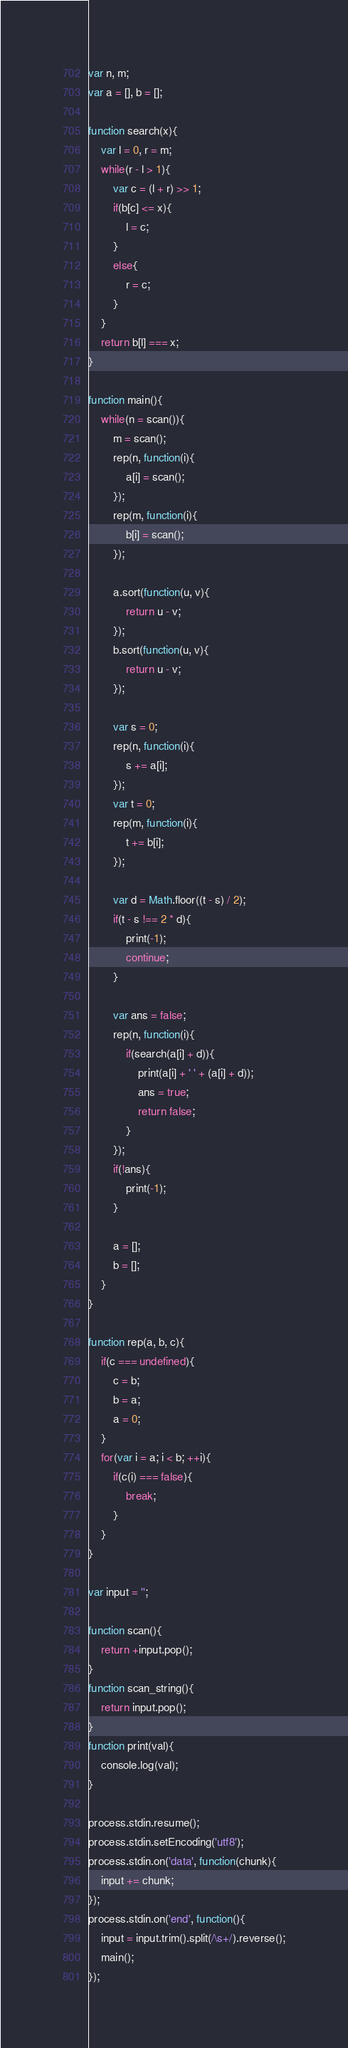<code> <loc_0><loc_0><loc_500><loc_500><_JavaScript_>var n, m;
var a = [], b = [];

function search(x){
	var l = 0, r = m;
	while(r - l > 1){
		var c = (l + r) >> 1;
		if(b[c] <= x){
			l = c;
		}
		else{
			r = c;
		}
	}
	return b[l] === x;
}

function main(){
	while(n = scan()){
		m = scan();
		rep(n, function(i){
			a[i] = scan();
		});
		rep(m, function(i){
			b[i] = scan();
		});

		a.sort(function(u, v){
			return u - v;
		});
		b.sort(function(u, v){
			return u - v;
		});

		var s = 0;
		rep(n, function(i){
			s += a[i];
		});
		var t = 0;
		rep(m, function(i){
			t += b[i];
		});

		var d = Math.floor((t - s) / 2);
		if(t - s !== 2 * d){
			print(-1);
			continue;
		}

		var ans = false;
		rep(n, function(i){
			if(search(a[i] + d)){
				print(a[i] + ' ' + (a[i] + d));
				ans = true;
				return false;
			}
		});
		if(!ans){
			print(-1);
		}

		a = [];
		b = [];
	}
}

function rep(a, b, c){
	if(c === undefined){
		c = b;
		b = a;
		a = 0;
	}
	for(var i = a; i < b; ++i){
		if(c(i) === false){
			break;
		}
	}
}

var input = '';

function scan(){
	return +input.pop();
}
function scan_string(){
	return input.pop();
} 
function print(val){
	console.log(val);
}
 
process.stdin.resume();
process.stdin.setEncoding('utf8');
process.stdin.on('data', function(chunk){
	input += chunk;
});
process.stdin.on('end', function(){
	input = input.trim().split(/\s+/).reverse();
	main();
});</code> 